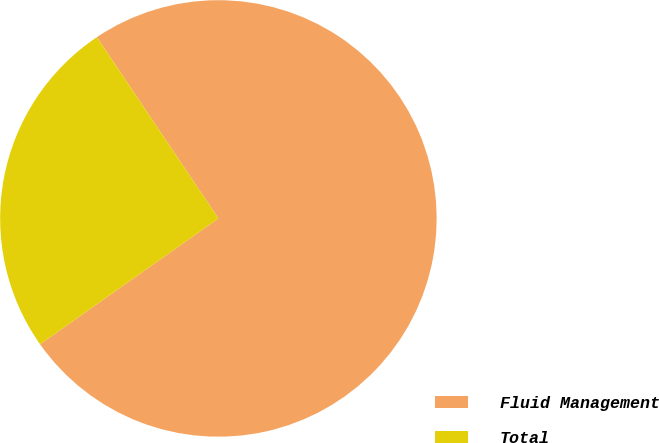Convert chart to OTSL. <chart><loc_0><loc_0><loc_500><loc_500><pie_chart><fcel>Fluid Management<fcel>Total<nl><fcel>74.62%<fcel>25.38%<nl></chart> 